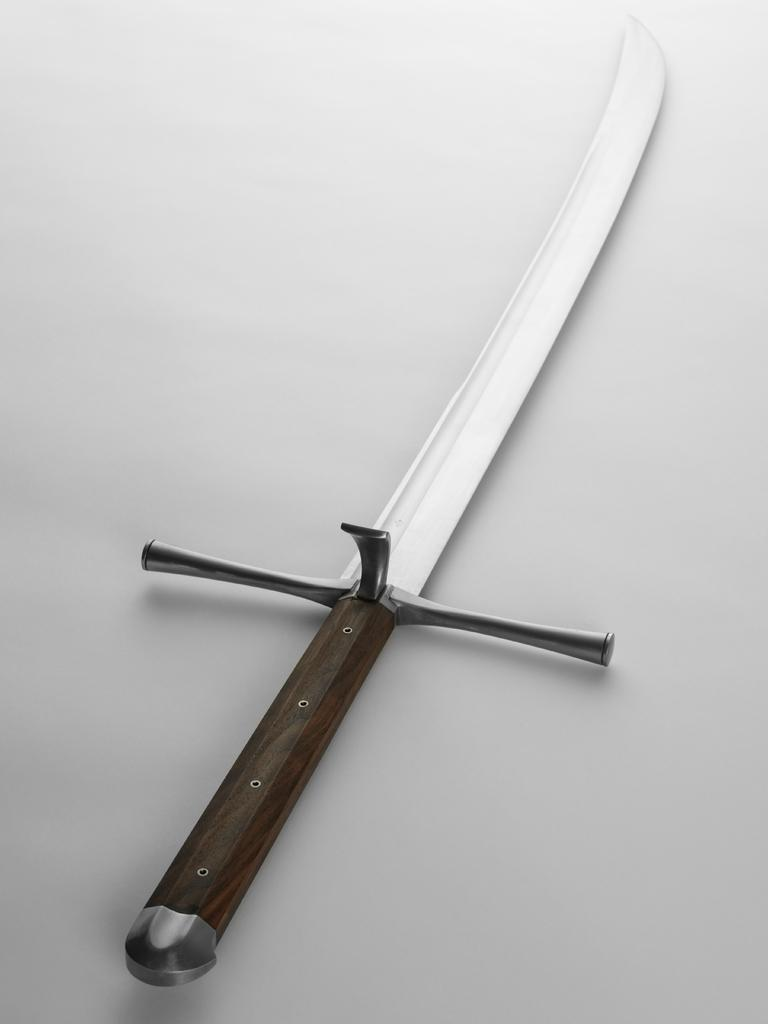What object can be seen in the image? There is a knife in the image. What color is the background of the image? The background of the image is white. Can you see a fireman in the image? No, there is no fireman present in the image. What type of arch can be seen in the image? There is no arch present in the image. 